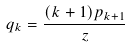<formula> <loc_0><loc_0><loc_500><loc_500>q _ { k } = \frac { ( k + 1 ) p _ { k + 1 } } { z }</formula> 